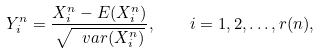<formula> <loc_0><loc_0><loc_500><loc_500>Y _ { i } ^ { n } = \frac { X _ { i } ^ { n } - E ( X _ { i } ^ { n } ) } { \sqrt { \ v a r ( X _ { i } ^ { n } ) } } , \quad i = 1 , 2 , \dots , r ( n ) ,</formula> 